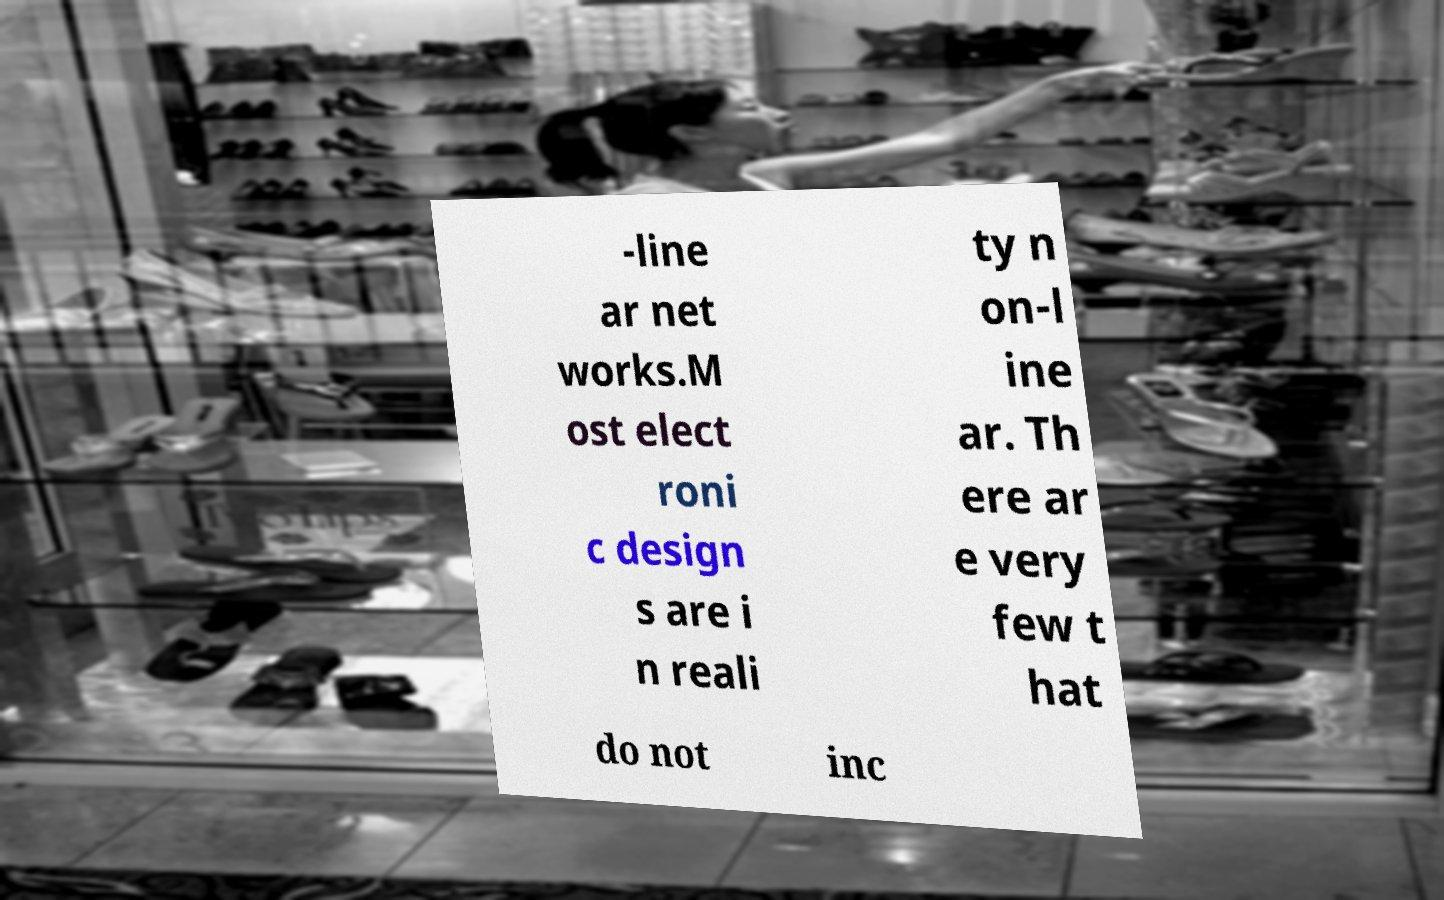Could you extract and type out the text from this image? -line ar net works.M ost elect roni c design s are i n reali ty n on-l ine ar. Th ere ar e very few t hat do not inc 